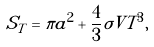<formula> <loc_0><loc_0><loc_500><loc_500>S _ { T } = \pi a ^ { 2 } + \frac { 4 } { 3 } \sigma V T ^ { 3 } ,</formula> 